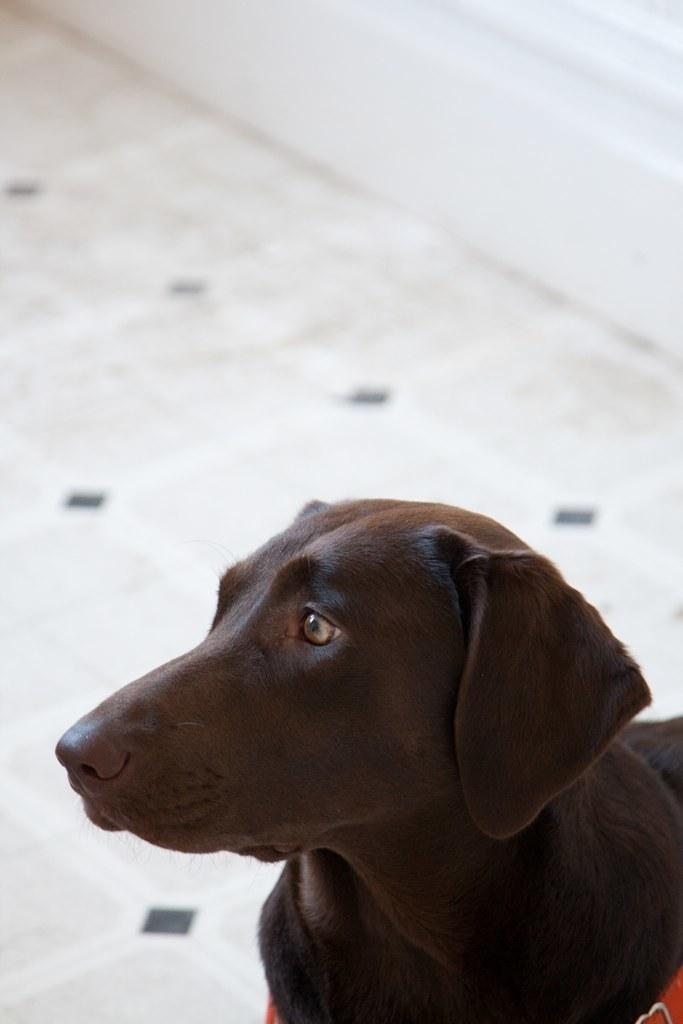What type of animal is present in the image? There is a dog in the image. Can you describe the background of the image? The background of the image is blurry. What time of day is it in the image, specifically in the afternoon? The time of day is not mentioned in the image, and there is no indication of the afternoon. Is the dog's aunt present in the image? There is no mention of an aunt or any other people in the image, only the dog. Can you see the roof of the house in the image? The roof of a house is not visible in the image; only the dog and the blurry background are present. 